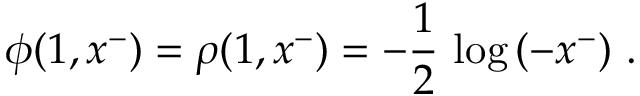Convert formula to latex. <formula><loc_0><loc_0><loc_500><loc_500>\phi ( 1 , x ^ { - } ) = \rho ( 1 , x ^ { - } ) = - { \frac { 1 } { 2 } } \, \log \, ( - x ^ { - } ) .</formula> 